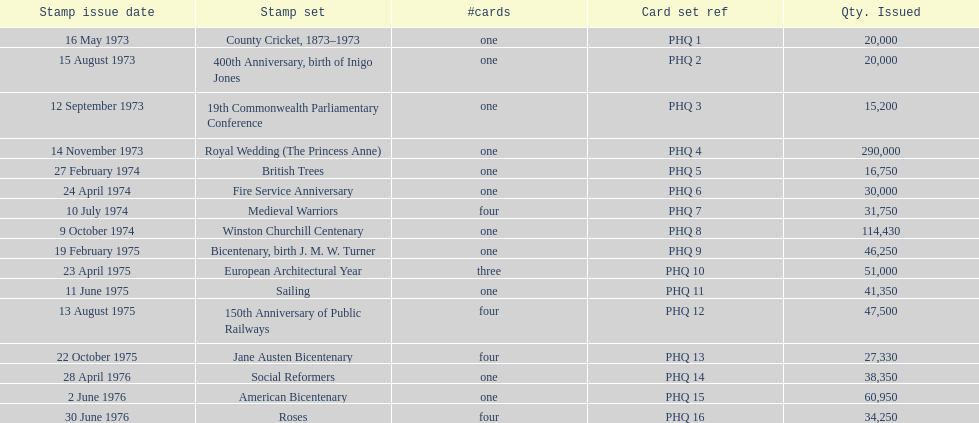Catalog each 200-year celebration stamp assortment Bicentenary, birth J. M. W. Turner, Jane Austen Bicentenary, American Bicentenary. 